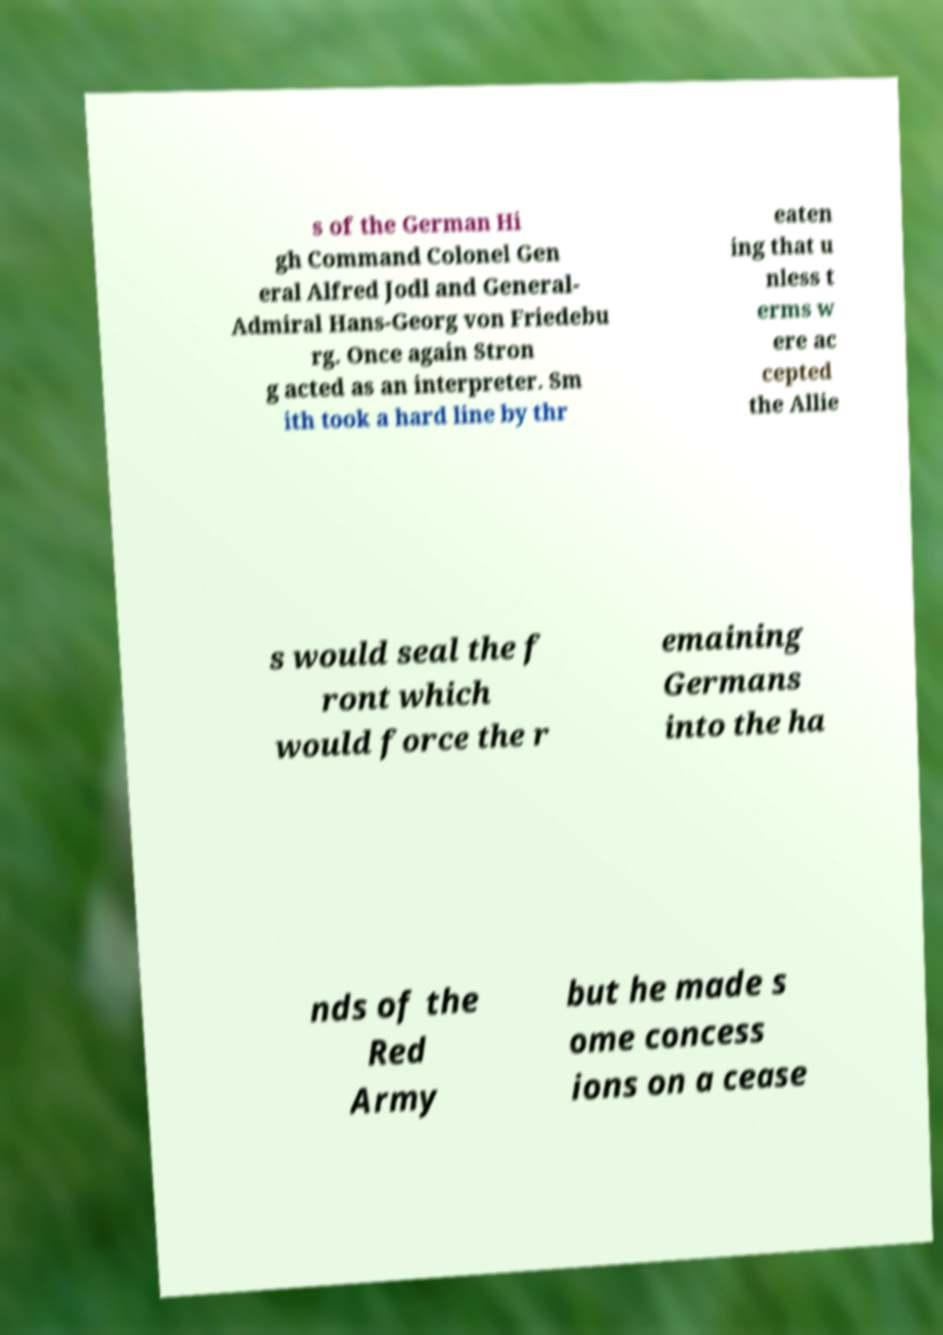Can you read and provide the text displayed in the image?This photo seems to have some interesting text. Can you extract and type it out for me? s of the German Hi gh Command Colonel Gen eral Alfred Jodl and General- Admiral Hans-Georg von Friedebu rg. Once again Stron g acted as an interpreter. Sm ith took a hard line by thr eaten ing that u nless t erms w ere ac cepted the Allie s would seal the f ront which would force the r emaining Germans into the ha nds of the Red Army but he made s ome concess ions on a cease 